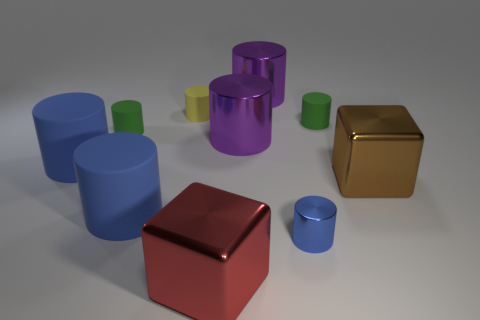How many blue cylinders must be subtracted to get 1 blue cylinders? 2 Subtract all yellow rubber cylinders. How many cylinders are left? 7 Subtract all yellow cylinders. How many cylinders are left? 7 Subtract all cylinders. How many objects are left? 2 Subtract 1 cylinders. How many cylinders are left? 7 Subtract all gray blocks. How many purple cylinders are left? 2 Subtract all rubber cylinders. Subtract all big brown objects. How many objects are left? 4 Add 6 small yellow rubber things. How many small yellow rubber things are left? 7 Add 5 tiny red matte objects. How many tiny red matte objects exist? 5 Subtract 0 gray spheres. How many objects are left? 10 